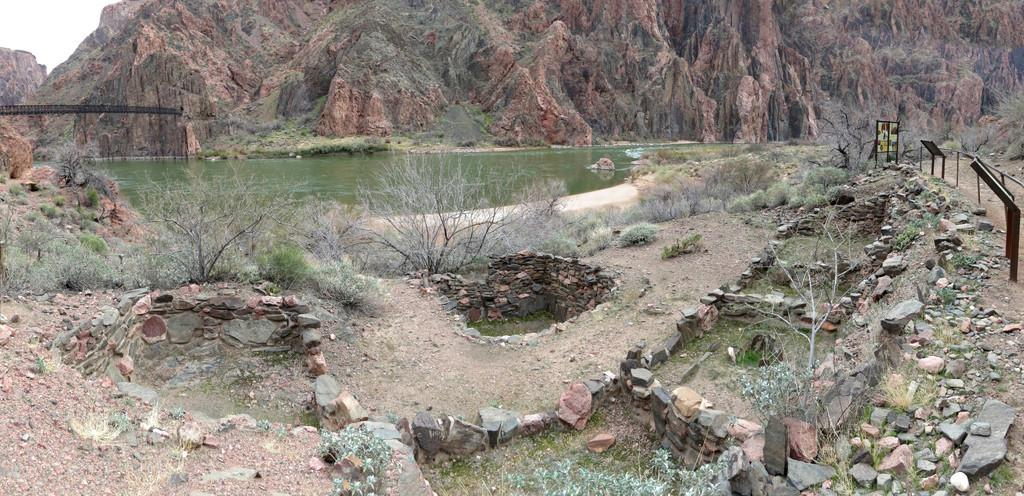What type of landscape can be seen in the image? The image features hills, water, trees, stones, rocks, grass, and the sky. Can you describe the water in the image? The water is visible in the image, but its specific characteristics are not mentioned in the facts. What type of vegetation is present in the image? Trees and grass are present in the image. What other natural elements can be seen in the image? Stones and rocks are visible in the image. What part of the natural environment is not visible in the image? The facts do not mention any man-made structures or elements. What type of silverware is visible in the image? There is no silverware present in the image; it features a natural landscape with hills, water, trees, stones, rocks, grass, and the sky. 